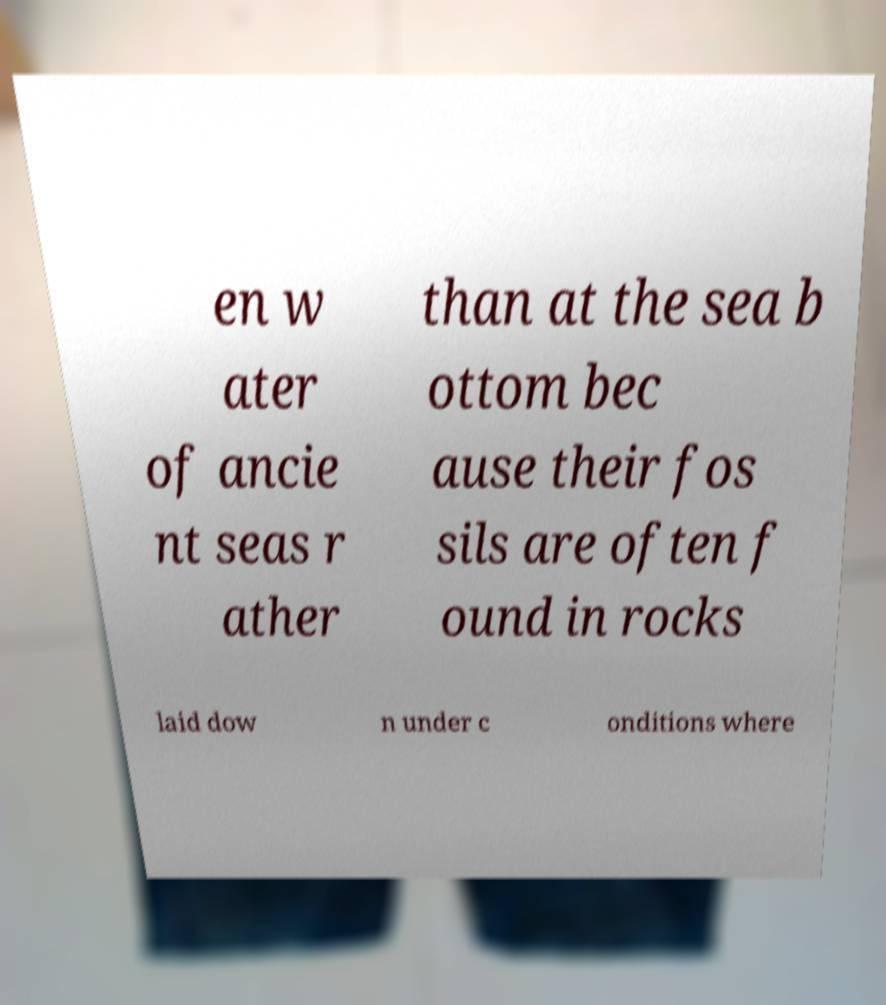For documentation purposes, I need the text within this image transcribed. Could you provide that? en w ater of ancie nt seas r ather than at the sea b ottom bec ause their fos sils are often f ound in rocks laid dow n under c onditions where 